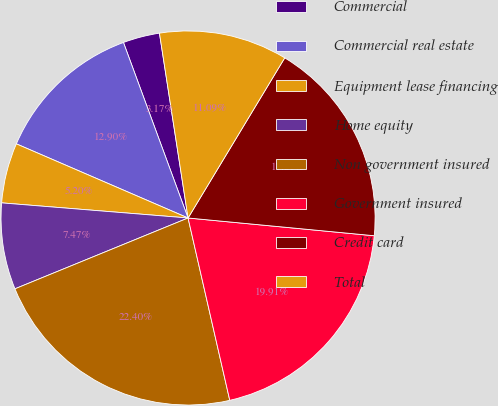<chart> <loc_0><loc_0><loc_500><loc_500><pie_chart><fcel>Commercial<fcel>Commercial real estate<fcel>Equipment lease financing<fcel>Home equity<fcel>Non government insured<fcel>Government insured<fcel>Credit card<fcel>Total<nl><fcel>3.17%<fcel>12.9%<fcel>5.2%<fcel>7.47%<fcel>22.4%<fcel>19.91%<fcel>17.87%<fcel>11.09%<nl></chart> 